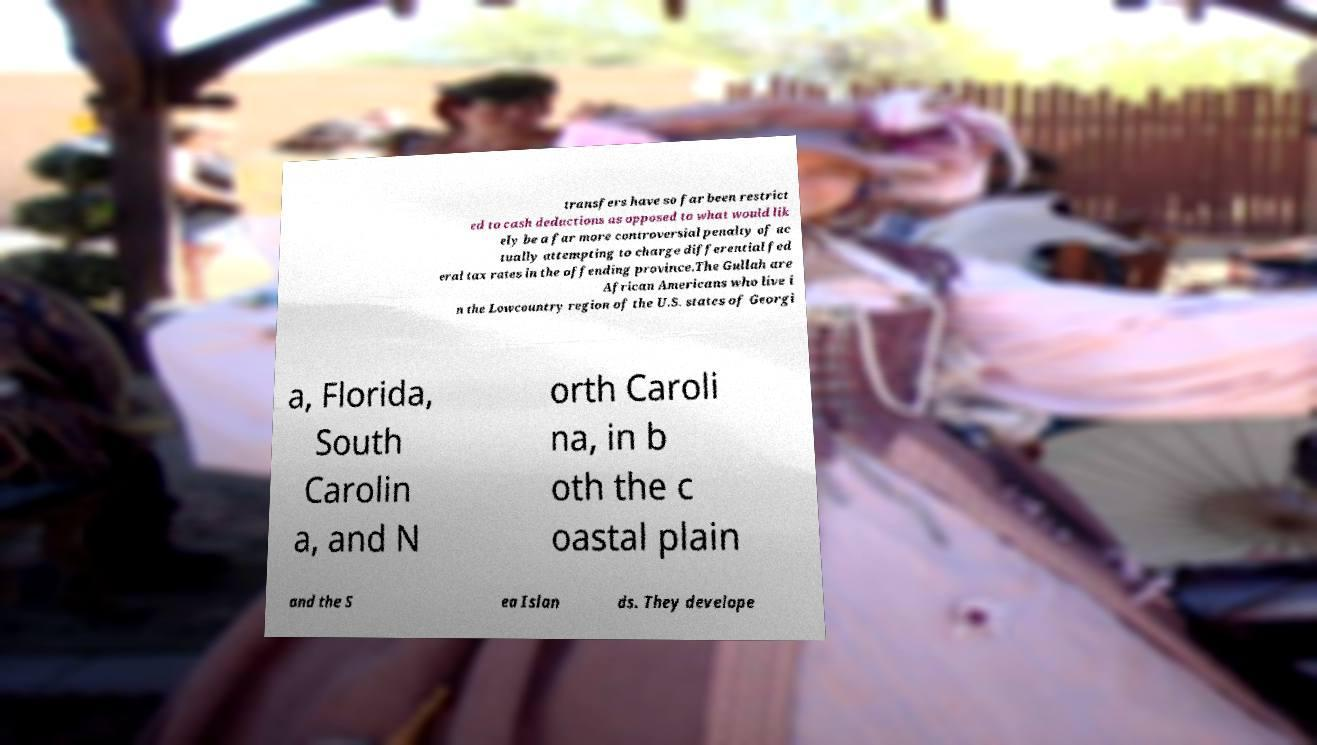Could you extract and type out the text from this image? transfers have so far been restrict ed to cash deductions as opposed to what would lik ely be a far more controversial penalty of ac tually attempting to charge differential fed eral tax rates in the offending province.The Gullah are African Americans who live i n the Lowcountry region of the U.S. states of Georgi a, Florida, South Carolin a, and N orth Caroli na, in b oth the c oastal plain and the S ea Islan ds. They develope 